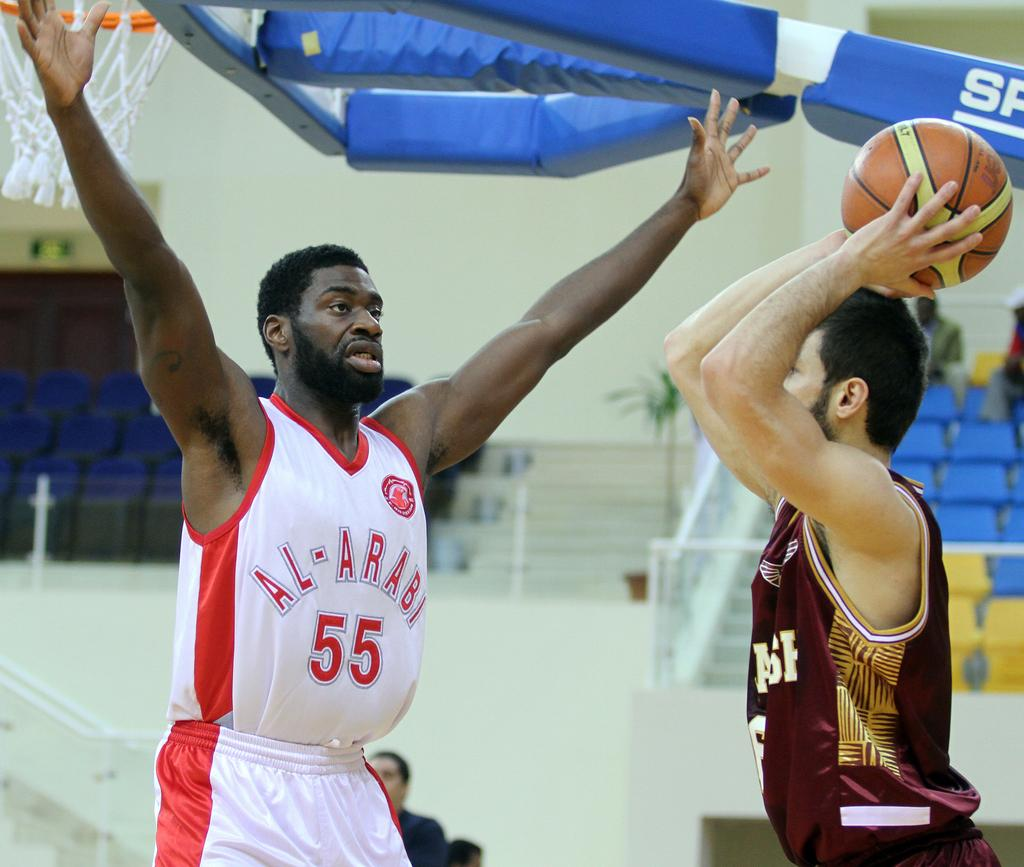<image>
Describe the image concisely. Basketball player that plays for Al-Arabi guarding someone. 